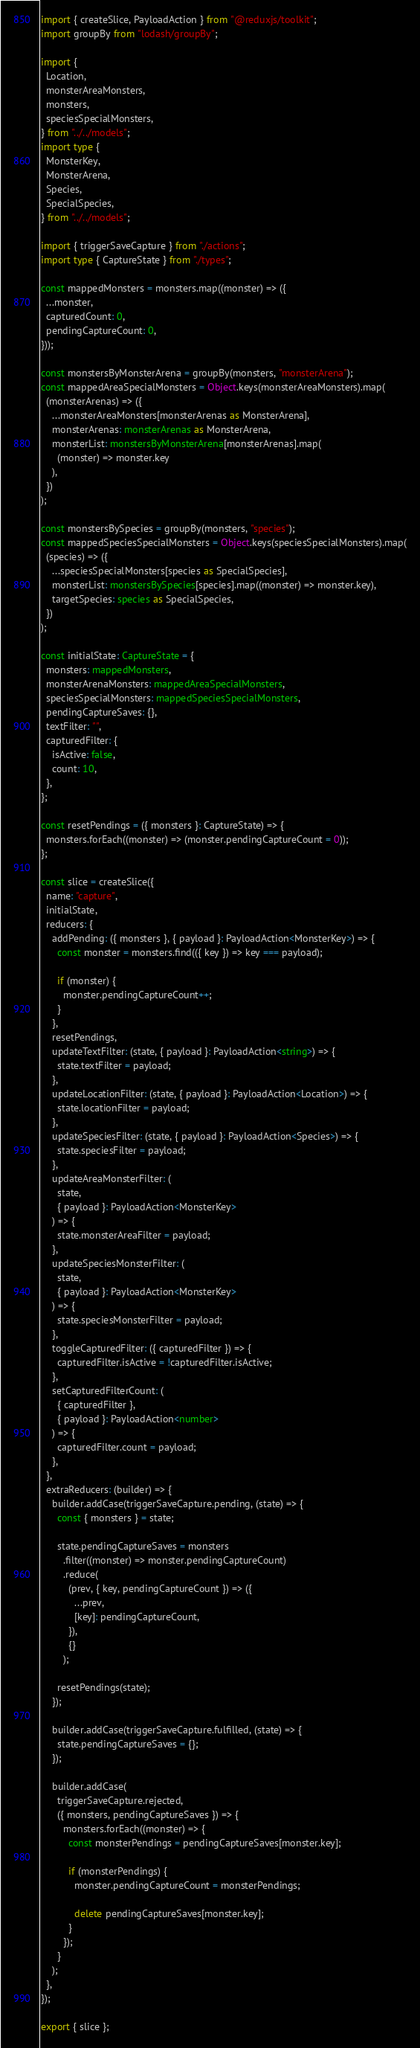<code> <loc_0><loc_0><loc_500><loc_500><_TypeScript_>import { createSlice, PayloadAction } from "@reduxjs/toolkit";
import groupBy from "lodash/groupBy";

import {
  Location,
  monsterAreaMonsters,
  monsters,
  speciesSpecialMonsters,
} from "../../models";
import type {
  MonsterKey,
  MonsterArena,
  Species,
  SpecialSpecies,
} from "../../models";

import { triggerSaveCapture } from "./actions";
import type { CaptureState } from "./types";

const mappedMonsters = monsters.map((monster) => ({
  ...monster,
  capturedCount: 0,
  pendingCaptureCount: 0,
}));

const monstersByMonsterArena = groupBy(monsters, "monsterArena");
const mappedAreaSpecialMonsters = Object.keys(monsterAreaMonsters).map(
  (monsterArenas) => ({
    ...monsterAreaMonsters[monsterArenas as MonsterArena],
    monsterArenas: monsterArenas as MonsterArena,
    monsterList: monstersByMonsterArena[monsterArenas].map(
      (monster) => monster.key
    ),
  })
);

const monstersBySpecies = groupBy(monsters, "species");
const mappedSpeciesSpecialMonsters = Object.keys(speciesSpecialMonsters).map(
  (species) => ({
    ...speciesSpecialMonsters[species as SpecialSpecies],
    monsterList: monstersBySpecies[species].map((monster) => monster.key),
    targetSpecies: species as SpecialSpecies,
  })
);

const initialState: CaptureState = {
  monsters: mappedMonsters,
  monsterArenaMonsters: mappedAreaSpecialMonsters,
  speciesSpecialMonsters: mappedSpeciesSpecialMonsters,
  pendingCaptureSaves: {},
  textFilter: "",
  capturedFilter: {
    isActive: false,
    count: 10,
  },
};

const resetPendings = ({ monsters }: CaptureState) => {
  monsters.forEach((monster) => (monster.pendingCaptureCount = 0));
};

const slice = createSlice({
  name: "capture",
  initialState,
  reducers: {
    addPending: ({ monsters }, { payload }: PayloadAction<MonsterKey>) => {
      const monster = monsters.find(({ key }) => key === payload);

      if (monster) {
        monster.pendingCaptureCount++;
      }
    },
    resetPendings,
    updateTextFilter: (state, { payload }: PayloadAction<string>) => {
      state.textFilter = payload;
    },
    updateLocationFilter: (state, { payload }: PayloadAction<Location>) => {
      state.locationFilter = payload;
    },
    updateSpeciesFilter: (state, { payload }: PayloadAction<Species>) => {
      state.speciesFilter = payload;
    },
    updateAreaMonsterFilter: (
      state,
      { payload }: PayloadAction<MonsterKey>
    ) => {
      state.monsterAreaFilter = payload;
    },
    updateSpeciesMonsterFilter: (
      state,
      { payload }: PayloadAction<MonsterKey>
    ) => {
      state.speciesMonsterFilter = payload;
    },
    toggleCapturedFilter: ({ capturedFilter }) => {
      capturedFilter.isActive = !capturedFilter.isActive;
    },
    setCapturedFilterCount: (
      { capturedFilter },
      { payload }: PayloadAction<number>
    ) => {
      capturedFilter.count = payload;
    },
  },
  extraReducers: (builder) => {
    builder.addCase(triggerSaveCapture.pending, (state) => {
      const { monsters } = state;

      state.pendingCaptureSaves = monsters
        .filter((monster) => monster.pendingCaptureCount)
        .reduce(
          (prev, { key, pendingCaptureCount }) => ({
            ...prev,
            [key]: pendingCaptureCount,
          }),
          {}
        );

      resetPendings(state);
    });

    builder.addCase(triggerSaveCapture.fulfilled, (state) => {
      state.pendingCaptureSaves = {};
    });

    builder.addCase(
      triggerSaveCapture.rejected,
      ({ monsters, pendingCaptureSaves }) => {
        monsters.forEach((monster) => {
          const monsterPendings = pendingCaptureSaves[monster.key];

          if (monsterPendings) {
            monster.pendingCaptureCount = monsterPendings;

            delete pendingCaptureSaves[monster.key];
          }
        });
      }
    );
  },
});

export { slice };
</code> 